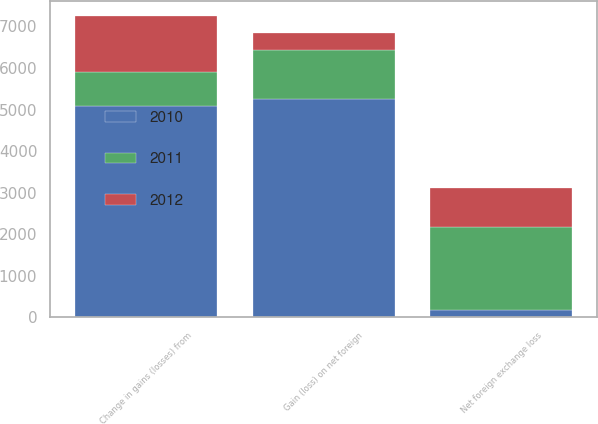Convert chart to OTSL. <chart><loc_0><loc_0><loc_500><loc_500><stacked_bar_chart><ecel><fcel>Change in gains (losses) from<fcel>Gain (loss) on net foreign<fcel>Net foreign exchange loss<nl><fcel>2012<fcel>1347<fcel>406<fcel>941<nl><fcel>2011<fcel>825<fcel>1181<fcel>2006<nl><fcel>2010<fcel>5074<fcel>5243<fcel>169<nl></chart> 